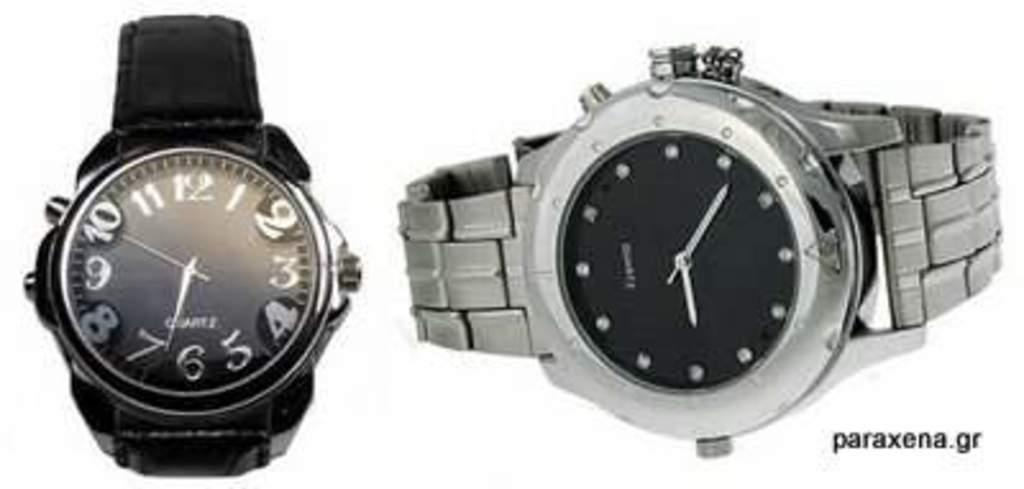<image>
Give a short and clear explanation of the subsequent image. A black wristwatch and a metal wrist watch available at paraxena.gr 